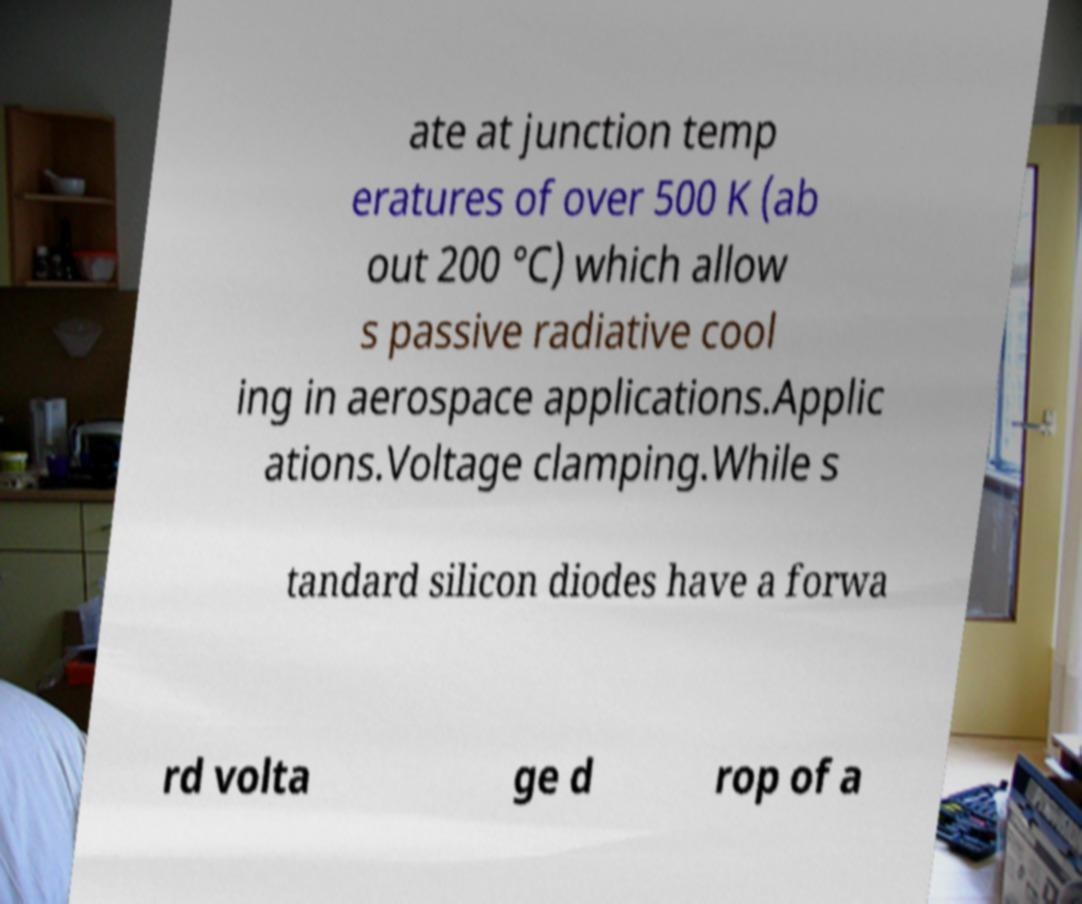There's text embedded in this image that I need extracted. Can you transcribe it verbatim? ate at junction temp eratures of over 500 K (ab out 200 °C) which allow s passive radiative cool ing in aerospace applications.Applic ations.Voltage clamping.While s tandard silicon diodes have a forwa rd volta ge d rop of a 